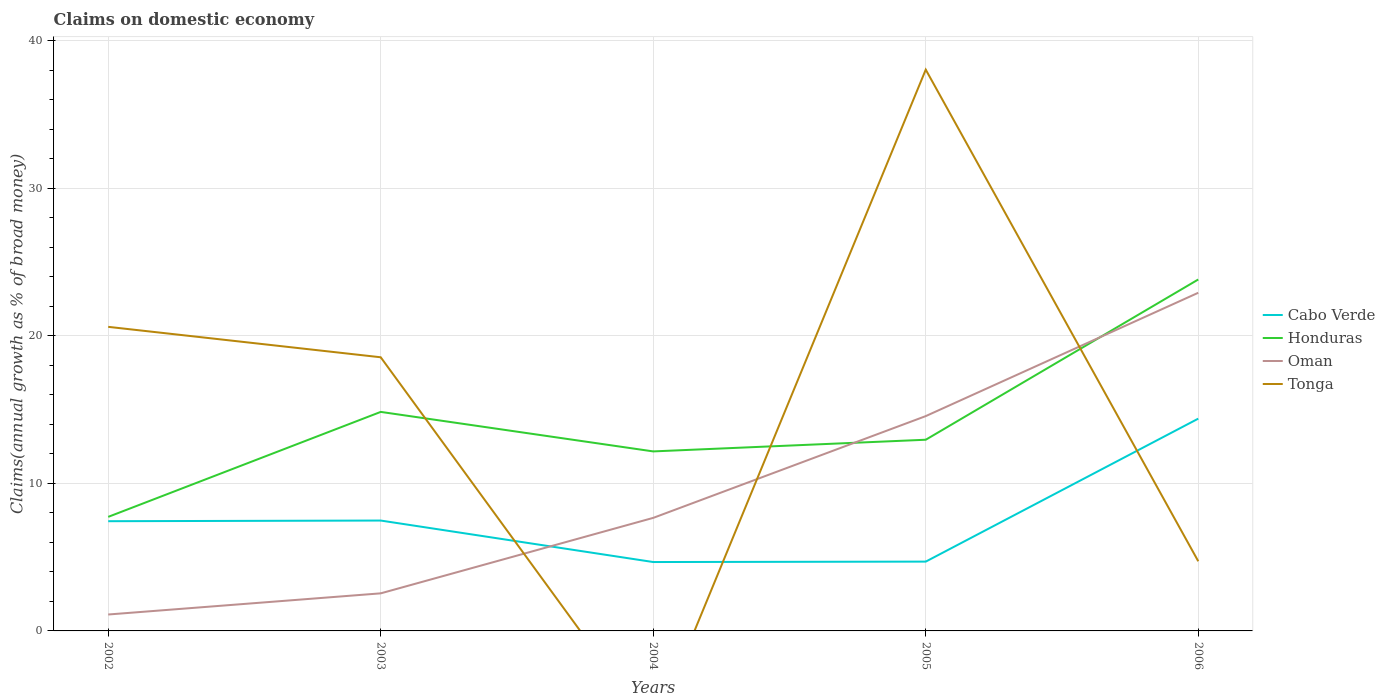How many different coloured lines are there?
Give a very brief answer. 4. Does the line corresponding to Tonga intersect with the line corresponding to Cabo Verde?
Keep it short and to the point. Yes. Is the number of lines equal to the number of legend labels?
Offer a very short reply. No. What is the total percentage of broad money claimed on domestic economy in Honduras in the graph?
Ensure brevity in your answer.  -11.65. What is the difference between the highest and the second highest percentage of broad money claimed on domestic economy in Cabo Verde?
Ensure brevity in your answer.  9.72. Is the percentage of broad money claimed on domestic economy in Cabo Verde strictly greater than the percentage of broad money claimed on domestic economy in Oman over the years?
Provide a succinct answer. No. How many lines are there?
Your answer should be very brief. 4. How many years are there in the graph?
Give a very brief answer. 5. Are the values on the major ticks of Y-axis written in scientific E-notation?
Offer a very short reply. No. Does the graph contain grids?
Ensure brevity in your answer.  Yes. Where does the legend appear in the graph?
Keep it short and to the point. Center right. How many legend labels are there?
Keep it short and to the point. 4. What is the title of the graph?
Give a very brief answer. Claims on domestic economy. What is the label or title of the X-axis?
Give a very brief answer. Years. What is the label or title of the Y-axis?
Give a very brief answer. Claims(annual growth as % of broad money). What is the Claims(annual growth as % of broad money) in Cabo Verde in 2002?
Your answer should be compact. 7.44. What is the Claims(annual growth as % of broad money) in Honduras in 2002?
Offer a very short reply. 7.73. What is the Claims(annual growth as % of broad money) in Oman in 2002?
Make the answer very short. 1.11. What is the Claims(annual growth as % of broad money) in Tonga in 2002?
Provide a succinct answer. 20.61. What is the Claims(annual growth as % of broad money) of Cabo Verde in 2003?
Your answer should be very brief. 7.48. What is the Claims(annual growth as % of broad money) of Honduras in 2003?
Provide a short and direct response. 14.84. What is the Claims(annual growth as % of broad money) in Oman in 2003?
Ensure brevity in your answer.  2.55. What is the Claims(annual growth as % of broad money) in Tonga in 2003?
Provide a succinct answer. 18.55. What is the Claims(annual growth as % of broad money) in Cabo Verde in 2004?
Give a very brief answer. 4.67. What is the Claims(annual growth as % of broad money) of Honduras in 2004?
Provide a succinct answer. 12.17. What is the Claims(annual growth as % of broad money) of Oman in 2004?
Your answer should be compact. 7.66. What is the Claims(annual growth as % of broad money) of Cabo Verde in 2005?
Your answer should be compact. 4.7. What is the Claims(annual growth as % of broad money) in Honduras in 2005?
Provide a succinct answer. 12.96. What is the Claims(annual growth as % of broad money) in Oman in 2005?
Make the answer very short. 14.56. What is the Claims(annual growth as % of broad money) in Tonga in 2005?
Your answer should be very brief. 38.04. What is the Claims(annual growth as % of broad money) of Cabo Verde in 2006?
Provide a succinct answer. 14.39. What is the Claims(annual growth as % of broad money) of Honduras in 2006?
Provide a short and direct response. 23.82. What is the Claims(annual growth as % of broad money) of Oman in 2006?
Your answer should be compact. 22.92. What is the Claims(annual growth as % of broad money) of Tonga in 2006?
Provide a succinct answer. 4.72. Across all years, what is the maximum Claims(annual growth as % of broad money) in Cabo Verde?
Provide a short and direct response. 14.39. Across all years, what is the maximum Claims(annual growth as % of broad money) in Honduras?
Your response must be concise. 23.82. Across all years, what is the maximum Claims(annual growth as % of broad money) in Oman?
Your answer should be very brief. 22.92. Across all years, what is the maximum Claims(annual growth as % of broad money) of Tonga?
Provide a short and direct response. 38.04. Across all years, what is the minimum Claims(annual growth as % of broad money) in Cabo Verde?
Make the answer very short. 4.67. Across all years, what is the minimum Claims(annual growth as % of broad money) of Honduras?
Provide a succinct answer. 7.73. Across all years, what is the minimum Claims(annual growth as % of broad money) in Oman?
Make the answer very short. 1.11. Across all years, what is the minimum Claims(annual growth as % of broad money) in Tonga?
Make the answer very short. 0. What is the total Claims(annual growth as % of broad money) in Cabo Verde in the graph?
Your answer should be compact. 38.67. What is the total Claims(annual growth as % of broad money) in Honduras in the graph?
Provide a short and direct response. 71.52. What is the total Claims(annual growth as % of broad money) of Oman in the graph?
Your answer should be very brief. 48.8. What is the total Claims(annual growth as % of broad money) of Tonga in the graph?
Offer a terse response. 81.92. What is the difference between the Claims(annual growth as % of broad money) in Cabo Verde in 2002 and that in 2003?
Offer a terse response. -0.05. What is the difference between the Claims(annual growth as % of broad money) of Honduras in 2002 and that in 2003?
Offer a very short reply. -7.11. What is the difference between the Claims(annual growth as % of broad money) of Oman in 2002 and that in 2003?
Keep it short and to the point. -1.43. What is the difference between the Claims(annual growth as % of broad money) in Tonga in 2002 and that in 2003?
Your answer should be very brief. 2.06. What is the difference between the Claims(annual growth as % of broad money) of Cabo Verde in 2002 and that in 2004?
Offer a very short reply. 2.77. What is the difference between the Claims(annual growth as % of broad money) in Honduras in 2002 and that in 2004?
Provide a succinct answer. -4.44. What is the difference between the Claims(annual growth as % of broad money) of Oman in 2002 and that in 2004?
Your response must be concise. -6.55. What is the difference between the Claims(annual growth as % of broad money) of Cabo Verde in 2002 and that in 2005?
Make the answer very short. 2.74. What is the difference between the Claims(annual growth as % of broad money) in Honduras in 2002 and that in 2005?
Make the answer very short. -5.23. What is the difference between the Claims(annual growth as % of broad money) of Oman in 2002 and that in 2005?
Offer a very short reply. -13.45. What is the difference between the Claims(annual growth as % of broad money) of Tonga in 2002 and that in 2005?
Offer a terse response. -17.43. What is the difference between the Claims(annual growth as % of broad money) of Cabo Verde in 2002 and that in 2006?
Your response must be concise. -6.95. What is the difference between the Claims(annual growth as % of broad money) in Honduras in 2002 and that in 2006?
Your response must be concise. -16.09. What is the difference between the Claims(annual growth as % of broad money) of Oman in 2002 and that in 2006?
Your response must be concise. -21.81. What is the difference between the Claims(annual growth as % of broad money) of Tonga in 2002 and that in 2006?
Your answer should be compact. 15.89. What is the difference between the Claims(annual growth as % of broad money) in Cabo Verde in 2003 and that in 2004?
Your response must be concise. 2.81. What is the difference between the Claims(annual growth as % of broad money) in Honduras in 2003 and that in 2004?
Provide a short and direct response. 2.68. What is the difference between the Claims(annual growth as % of broad money) in Oman in 2003 and that in 2004?
Ensure brevity in your answer.  -5.12. What is the difference between the Claims(annual growth as % of broad money) in Cabo Verde in 2003 and that in 2005?
Provide a succinct answer. 2.78. What is the difference between the Claims(annual growth as % of broad money) in Honduras in 2003 and that in 2005?
Your response must be concise. 1.89. What is the difference between the Claims(annual growth as % of broad money) in Oman in 2003 and that in 2005?
Your answer should be compact. -12.01. What is the difference between the Claims(annual growth as % of broad money) of Tonga in 2003 and that in 2005?
Make the answer very short. -19.5. What is the difference between the Claims(annual growth as % of broad money) of Cabo Verde in 2003 and that in 2006?
Give a very brief answer. -6.91. What is the difference between the Claims(annual growth as % of broad money) in Honduras in 2003 and that in 2006?
Offer a terse response. -8.98. What is the difference between the Claims(annual growth as % of broad money) in Oman in 2003 and that in 2006?
Provide a succinct answer. -20.37. What is the difference between the Claims(annual growth as % of broad money) of Tonga in 2003 and that in 2006?
Your answer should be compact. 13.83. What is the difference between the Claims(annual growth as % of broad money) of Cabo Verde in 2004 and that in 2005?
Your response must be concise. -0.03. What is the difference between the Claims(annual growth as % of broad money) of Honduras in 2004 and that in 2005?
Your answer should be very brief. -0.79. What is the difference between the Claims(annual growth as % of broad money) of Oman in 2004 and that in 2005?
Ensure brevity in your answer.  -6.9. What is the difference between the Claims(annual growth as % of broad money) in Cabo Verde in 2004 and that in 2006?
Provide a succinct answer. -9.72. What is the difference between the Claims(annual growth as % of broad money) of Honduras in 2004 and that in 2006?
Provide a succinct answer. -11.65. What is the difference between the Claims(annual growth as % of broad money) in Oman in 2004 and that in 2006?
Ensure brevity in your answer.  -15.26. What is the difference between the Claims(annual growth as % of broad money) in Cabo Verde in 2005 and that in 2006?
Give a very brief answer. -9.69. What is the difference between the Claims(annual growth as % of broad money) in Honduras in 2005 and that in 2006?
Offer a very short reply. -10.86. What is the difference between the Claims(annual growth as % of broad money) of Oman in 2005 and that in 2006?
Your answer should be very brief. -8.36. What is the difference between the Claims(annual growth as % of broad money) in Tonga in 2005 and that in 2006?
Your response must be concise. 33.32. What is the difference between the Claims(annual growth as % of broad money) in Cabo Verde in 2002 and the Claims(annual growth as % of broad money) in Honduras in 2003?
Your answer should be compact. -7.41. What is the difference between the Claims(annual growth as % of broad money) in Cabo Verde in 2002 and the Claims(annual growth as % of broad money) in Oman in 2003?
Your answer should be compact. 4.89. What is the difference between the Claims(annual growth as % of broad money) in Cabo Verde in 2002 and the Claims(annual growth as % of broad money) in Tonga in 2003?
Keep it short and to the point. -11.11. What is the difference between the Claims(annual growth as % of broad money) in Honduras in 2002 and the Claims(annual growth as % of broad money) in Oman in 2003?
Your answer should be compact. 5.18. What is the difference between the Claims(annual growth as % of broad money) in Honduras in 2002 and the Claims(annual growth as % of broad money) in Tonga in 2003?
Provide a succinct answer. -10.82. What is the difference between the Claims(annual growth as % of broad money) of Oman in 2002 and the Claims(annual growth as % of broad money) of Tonga in 2003?
Make the answer very short. -17.43. What is the difference between the Claims(annual growth as % of broad money) in Cabo Verde in 2002 and the Claims(annual growth as % of broad money) in Honduras in 2004?
Provide a succinct answer. -4.73. What is the difference between the Claims(annual growth as % of broad money) in Cabo Verde in 2002 and the Claims(annual growth as % of broad money) in Oman in 2004?
Keep it short and to the point. -0.23. What is the difference between the Claims(annual growth as % of broad money) of Honduras in 2002 and the Claims(annual growth as % of broad money) of Oman in 2004?
Your answer should be very brief. 0.07. What is the difference between the Claims(annual growth as % of broad money) of Cabo Verde in 2002 and the Claims(annual growth as % of broad money) of Honduras in 2005?
Provide a short and direct response. -5.52. What is the difference between the Claims(annual growth as % of broad money) of Cabo Verde in 2002 and the Claims(annual growth as % of broad money) of Oman in 2005?
Your answer should be very brief. -7.12. What is the difference between the Claims(annual growth as % of broad money) in Cabo Verde in 2002 and the Claims(annual growth as % of broad money) in Tonga in 2005?
Your answer should be very brief. -30.61. What is the difference between the Claims(annual growth as % of broad money) in Honduras in 2002 and the Claims(annual growth as % of broad money) in Oman in 2005?
Offer a very short reply. -6.83. What is the difference between the Claims(annual growth as % of broad money) in Honduras in 2002 and the Claims(annual growth as % of broad money) in Tonga in 2005?
Ensure brevity in your answer.  -30.31. What is the difference between the Claims(annual growth as % of broad money) in Oman in 2002 and the Claims(annual growth as % of broad money) in Tonga in 2005?
Keep it short and to the point. -36.93. What is the difference between the Claims(annual growth as % of broad money) in Cabo Verde in 2002 and the Claims(annual growth as % of broad money) in Honduras in 2006?
Give a very brief answer. -16.38. What is the difference between the Claims(annual growth as % of broad money) of Cabo Verde in 2002 and the Claims(annual growth as % of broad money) of Oman in 2006?
Provide a short and direct response. -15.48. What is the difference between the Claims(annual growth as % of broad money) in Cabo Verde in 2002 and the Claims(annual growth as % of broad money) in Tonga in 2006?
Offer a terse response. 2.71. What is the difference between the Claims(annual growth as % of broad money) in Honduras in 2002 and the Claims(annual growth as % of broad money) in Oman in 2006?
Your answer should be compact. -15.19. What is the difference between the Claims(annual growth as % of broad money) of Honduras in 2002 and the Claims(annual growth as % of broad money) of Tonga in 2006?
Provide a succinct answer. 3.01. What is the difference between the Claims(annual growth as % of broad money) in Oman in 2002 and the Claims(annual growth as % of broad money) in Tonga in 2006?
Provide a short and direct response. -3.61. What is the difference between the Claims(annual growth as % of broad money) of Cabo Verde in 2003 and the Claims(annual growth as % of broad money) of Honduras in 2004?
Provide a succinct answer. -4.69. What is the difference between the Claims(annual growth as % of broad money) in Cabo Verde in 2003 and the Claims(annual growth as % of broad money) in Oman in 2004?
Provide a short and direct response. -0.18. What is the difference between the Claims(annual growth as % of broad money) of Honduras in 2003 and the Claims(annual growth as % of broad money) of Oman in 2004?
Provide a succinct answer. 7.18. What is the difference between the Claims(annual growth as % of broad money) in Cabo Verde in 2003 and the Claims(annual growth as % of broad money) in Honduras in 2005?
Provide a succinct answer. -5.48. What is the difference between the Claims(annual growth as % of broad money) of Cabo Verde in 2003 and the Claims(annual growth as % of broad money) of Oman in 2005?
Ensure brevity in your answer.  -7.08. What is the difference between the Claims(annual growth as % of broad money) of Cabo Verde in 2003 and the Claims(annual growth as % of broad money) of Tonga in 2005?
Provide a short and direct response. -30.56. What is the difference between the Claims(annual growth as % of broad money) of Honduras in 2003 and the Claims(annual growth as % of broad money) of Oman in 2005?
Provide a short and direct response. 0.28. What is the difference between the Claims(annual growth as % of broad money) of Honduras in 2003 and the Claims(annual growth as % of broad money) of Tonga in 2005?
Offer a terse response. -23.2. What is the difference between the Claims(annual growth as % of broad money) in Oman in 2003 and the Claims(annual growth as % of broad money) in Tonga in 2005?
Give a very brief answer. -35.5. What is the difference between the Claims(annual growth as % of broad money) in Cabo Verde in 2003 and the Claims(annual growth as % of broad money) in Honduras in 2006?
Your response must be concise. -16.34. What is the difference between the Claims(annual growth as % of broad money) in Cabo Verde in 2003 and the Claims(annual growth as % of broad money) in Oman in 2006?
Provide a short and direct response. -15.44. What is the difference between the Claims(annual growth as % of broad money) of Cabo Verde in 2003 and the Claims(annual growth as % of broad money) of Tonga in 2006?
Offer a terse response. 2.76. What is the difference between the Claims(annual growth as % of broad money) of Honduras in 2003 and the Claims(annual growth as % of broad money) of Oman in 2006?
Ensure brevity in your answer.  -8.07. What is the difference between the Claims(annual growth as % of broad money) of Honduras in 2003 and the Claims(annual growth as % of broad money) of Tonga in 2006?
Give a very brief answer. 10.12. What is the difference between the Claims(annual growth as % of broad money) in Oman in 2003 and the Claims(annual growth as % of broad money) in Tonga in 2006?
Provide a succinct answer. -2.17. What is the difference between the Claims(annual growth as % of broad money) in Cabo Verde in 2004 and the Claims(annual growth as % of broad money) in Honduras in 2005?
Your response must be concise. -8.29. What is the difference between the Claims(annual growth as % of broad money) in Cabo Verde in 2004 and the Claims(annual growth as % of broad money) in Oman in 2005?
Offer a very short reply. -9.89. What is the difference between the Claims(annual growth as % of broad money) of Cabo Verde in 2004 and the Claims(annual growth as % of broad money) of Tonga in 2005?
Give a very brief answer. -33.37. What is the difference between the Claims(annual growth as % of broad money) in Honduras in 2004 and the Claims(annual growth as % of broad money) in Oman in 2005?
Your answer should be compact. -2.39. What is the difference between the Claims(annual growth as % of broad money) in Honduras in 2004 and the Claims(annual growth as % of broad money) in Tonga in 2005?
Your response must be concise. -25.88. What is the difference between the Claims(annual growth as % of broad money) of Oman in 2004 and the Claims(annual growth as % of broad money) of Tonga in 2005?
Ensure brevity in your answer.  -30.38. What is the difference between the Claims(annual growth as % of broad money) of Cabo Verde in 2004 and the Claims(annual growth as % of broad money) of Honduras in 2006?
Your answer should be very brief. -19.15. What is the difference between the Claims(annual growth as % of broad money) of Cabo Verde in 2004 and the Claims(annual growth as % of broad money) of Oman in 2006?
Provide a short and direct response. -18.25. What is the difference between the Claims(annual growth as % of broad money) of Cabo Verde in 2004 and the Claims(annual growth as % of broad money) of Tonga in 2006?
Your answer should be compact. -0.05. What is the difference between the Claims(annual growth as % of broad money) in Honduras in 2004 and the Claims(annual growth as % of broad money) in Oman in 2006?
Offer a very short reply. -10.75. What is the difference between the Claims(annual growth as % of broad money) in Honduras in 2004 and the Claims(annual growth as % of broad money) in Tonga in 2006?
Offer a very short reply. 7.45. What is the difference between the Claims(annual growth as % of broad money) in Oman in 2004 and the Claims(annual growth as % of broad money) in Tonga in 2006?
Your answer should be compact. 2.94. What is the difference between the Claims(annual growth as % of broad money) in Cabo Verde in 2005 and the Claims(annual growth as % of broad money) in Honduras in 2006?
Offer a very short reply. -19.12. What is the difference between the Claims(annual growth as % of broad money) in Cabo Verde in 2005 and the Claims(annual growth as % of broad money) in Oman in 2006?
Keep it short and to the point. -18.22. What is the difference between the Claims(annual growth as % of broad money) in Cabo Verde in 2005 and the Claims(annual growth as % of broad money) in Tonga in 2006?
Give a very brief answer. -0.02. What is the difference between the Claims(annual growth as % of broad money) of Honduras in 2005 and the Claims(annual growth as % of broad money) of Oman in 2006?
Keep it short and to the point. -9.96. What is the difference between the Claims(annual growth as % of broad money) of Honduras in 2005 and the Claims(annual growth as % of broad money) of Tonga in 2006?
Offer a terse response. 8.24. What is the difference between the Claims(annual growth as % of broad money) of Oman in 2005 and the Claims(annual growth as % of broad money) of Tonga in 2006?
Provide a short and direct response. 9.84. What is the average Claims(annual growth as % of broad money) of Cabo Verde per year?
Ensure brevity in your answer.  7.73. What is the average Claims(annual growth as % of broad money) of Honduras per year?
Your response must be concise. 14.3. What is the average Claims(annual growth as % of broad money) of Oman per year?
Offer a very short reply. 9.76. What is the average Claims(annual growth as % of broad money) of Tonga per year?
Offer a terse response. 16.38. In the year 2002, what is the difference between the Claims(annual growth as % of broad money) of Cabo Verde and Claims(annual growth as % of broad money) of Honduras?
Keep it short and to the point. -0.29. In the year 2002, what is the difference between the Claims(annual growth as % of broad money) in Cabo Verde and Claims(annual growth as % of broad money) in Oman?
Provide a succinct answer. 6.32. In the year 2002, what is the difference between the Claims(annual growth as % of broad money) of Cabo Verde and Claims(annual growth as % of broad money) of Tonga?
Offer a terse response. -13.17. In the year 2002, what is the difference between the Claims(annual growth as % of broad money) of Honduras and Claims(annual growth as % of broad money) of Oman?
Offer a terse response. 6.62. In the year 2002, what is the difference between the Claims(annual growth as % of broad money) of Honduras and Claims(annual growth as % of broad money) of Tonga?
Provide a short and direct response. -12.88. In the year 2002, what is the difference between the Claims(annual growth as % of broad money) in Oman and Claims(annual growth as % of broad money) in Tonga?
Offer a terse response. -19.5. In the year 2003, what is the difference between the Claims(annual growth as % of broad money) of Cabo Verde and Claims(annual growth as % of broad money) of Honduras?
Provide a short and direct response. -7.36. In the year 2003, what is the difference between the Claims(annual growth as % of broad money) in Cabo Verde and Claims(annual growth as % of broad money) in Oman?
Give a very brief answer. 4.93. In the year 2003, what is the difference between the Claims(annual growth as % of broad money) in Cabo Verde and Claims(annual growth as % of broad money) in Tonga?
Your answer should be very brief. -11.07. In the year 2003, what is the difference between the Claims(annual growth as % of broad money) of Honduras and Claims(annual growth as % of broad money) of Oman?
Make the answer very short. 12.3. In the year 2003, what is the difference between the Claims(annual growth as % of broad money) in Honduras and Claims(annual growth as % of broad money) in Tonga?
Ensure brevity in your answer.  -3.7. In the year 2003, what is the difference between the Claims(annual growth as % of broad money) in Oman and Claims(annual growth as % of broad money) in Tonga?
Your answer should be very brief. -16. In the year 2004, what is the difference between the Claims(annual growth as % of broad money) of Cabo Verde and Claims(annual growth as % of broad money) of Honduras?
Keep it short and to the point. -7.5. In the year 2004, what is the difference between the Claims(annual growth as % of broad money) of Cabo Verde and Claims(annual growth as % of broad money) of Oman?
Ensure brevity in your answer.  -2.99. In the year 2004, what is the difference between the Claims(annual growth as % of broad money) of Honduras and Claims(annual growth as % of broad money) of Oman?
Provide a short and direct response. 4.5. In the year 2005, what is the difference between the Claims(annual growth as % of broad money) of Cabo Verde and Claims(annual growth as % of broad money) of Honduras?
Your answer should be compact. -8.26. In the year 2005, what is the difference between the Claims(annual growth as % of broad money) in Cabo Verde and Claims(annual growth as % of broad money) in Oman?
Keep it short and to the point. -9.86. In the year 2005, what is the difference between the Claims(annual growth as % of broad money) in Cabo Verde and Claims(annual growth as % of broad money) in Tonga?
Offer a terse response. -33.35. In the year 2005, what is the difference between the Claims(annual growth as % of broad money) in Honduras and Claims(annual growth as % of broad money) in Oman?
Your answer should be very brief. -1.6. In the year 2005, what is the difference between the Claims(annual growth as % of broad money) of Honduras and Claims(annual growth as % of broad money) of Tonga?
Keep it short and to the point. -25.08. In the year 2005, what is the difference between the Claims(annual growth as % of broad money) in Oman and Claims(annual growth as % of broad money) in Tonga?
Provide a succinct answer. -23.48. In the year 2006, what is the difference between the Claims(annual growth as % of broad money) of Cabo Verde and Claims(annual growth as % of broad money) of Honduras?
Offer a very short reply. -9.43. In the year 2006, what is the difference between the Claims(annual growth as % of broad money) of Cabo Verde and Claims(annual growth as % of broad money) of Oman?
Offer a very short reply. -8.53. In the year 2006, what is the difference between the Claims(annual growth as % of broad money) in Cabo Verde and Claims(annual growth as % of broad money) in Tonga?
Give a very brief answer. 9.67. In the year 2006, what is the difference between the Claims(annual growth as % of broad money) in Honduras and Claims(annual growth as % of broad money) in Oman?
Your response must be concise. 0.9. In the year 2006, what is the difference between the Claims(annual growth as % of broad money) in Honduras and Claims(annual growth as % of broad money) in Tonga?
Ensure brevity in your answer.  19.1. In the year 2006, what is the difference between the Claims(annual growth as % of broad money) in Oman and Claims(annual growth as % of broad money) in Tonga?
Your answer should be very brief. 18.2. What is the ratio of the Claims(annual growth as % of broad money) of Cabo Verde in 2002 to that in 2003?
Your response must be concise. 0.99. What is the ratio of the Claims(annual growth as % of broad money) in Honduras in 2002 to that in 2003?
Provide a short and direct response. 0.52. What is the ratio of the Claims(annual growth as % of broad money) of Oman in 2002 to that in 2003?
Your response must be concise. 0.44. What is the ratio of the Claims(annual growth as % of broad money) in Tonga in 2002 to that in 2003?
Your response must be concise. 1.11. What is the ratio of the Claims(annual growth as % of broad money) of Cabo Verde in 2002 to that in 2004?
Offer a terse response. 1.59. What is the ratio of the Claims(annual growth as % of broad money) in Honduras in 2002 to that in 2004?
Ensure brevity in your answer.  0.64. What is the ratio of the Claims(annual growth as % of broad money) in Oman in 2002 to that in 2004?
Provide a succinct answer. 0.15. What is the ratio of the Claims(annual growth as % of broad money) of Cabo Verde in 2002 to that in 2005?
Offer a terse response. 1.58. What is the ratio of the Claims(annual growth as % of broad money) in Honduras in 2002 to that in 2005?
Keep it short and to the point. 0.6. What is the ratio of the Claims(annual growth as % of broad money) in Oman in 2002 to that in 2005?
Ensure brevity in your answer.  0.08. What is the ratio of the Claims(annual growth as % of broad money) of Tonga in 2002 to that in 2005?
Your answer should be compact. 0.54. What is the ratio of the Claims(annual growth as % of broad money) of Cabo Verde in 2002 to that in 2006?
Offer a very short reply. 0.52. What is the ratio of the Claims(annual growth as % of broad money) in Honduras in 2002 to that in 2006?
Your answer should be very brief. 0.32. What is the ratio of the Claims(annual growth as % of broad money) of Oman in 2002 to that in 2006?
Give a very brief answer. 0.05. What is the ratio of the Claims(annual growth as % of broad money) of Tonga in 2002 to that in 2006?
Give a very brief answer. 4.37. What is the ratio of the Claims(annual growth as % of broad money) of Cabo Verde in 2003 to that in 2004?
Keep it short and to the point. 1.6. What is the ratio of the Claims(annual growth as % of broad money) of Honduras in 2003 to that in 2004?
Your answer should be very brief. 1.22. What is the ratio of the Claims(annual growth as % of broad money) of Oman in 2003 to that in 2004?
Keep it short and to the point. 0.33. What is the ratio of the Claims(annual growth as % of broad money) in Cabo Verde in 2003 to that in 2005?
Your answer should be compact. 1.59. What is the ratio of the Claims(annual growth as % of broad money) of Honduras in 2003 to that in 2005?
Your answer should be compact. 1.15. What is the ratio of the Claims(annual growth as % of broad money) of Oman in 2003 to that in 2005?
Your answer should be compact. 0.17. What is the ratio of the Claims(annual growth as % of broad money) of Tonga in 2003 to that in 2005?
Your response must be concise. 0.49. What is the ratio of the Claims(annual growth as % of broad money) in Cabo Verde in 2003 to that in 2006?
Make the answer very short. 0.52. What is the ratio of the Claims(annual growth as % of broad money) of Honduras in 2003 to that in 2006?
Your response must be concise. 0.62. What is the ratio of the Claims(annual growth as % of broad money) in Oman in 2003 to that in 2006?
Give a very brief answer. 0.11. What is the ratio of the Claims(annual growth as % of broad money) of Tonga in 2003 to that in 2006?
Ensure brevity in your answer.  3.93. What is the ratio of the Claims(annual growth as % of broad money) in Cabo Verde in 2004 to that in 2005?
Offer a terse response. 0.99. What is the ratio of the Claims(annual growth as % of broad money) of Honduras in 2004 to that in 2005?
Your answer should be compact. 0.94. What is the ratio of the Claims(annual growth as % of broad money) of Oman in 2004 to that in 2005?
Your answer should be compact. 0.53. What is the ratio of the Claims(annual growth as % of broad money) of Cabo Verde in 2004 to that in 2006?
Your answer should be very brief. 0.32. What is the ratio of the Claims(annual growth as % of broad money) in Honduras in 2004 to that in 2006?
Give a very brief answer. 0.51. What is the ratio of the Claims(annual growth as % of broad money) in Oman in 2004 to that in 2006?
Provide a succinct answer. 0.33. What is the ratio of the Claims(annual growth as % of broad money) of Cabo Verde in 2005 to that in 2006?
Offer a terse response. 0.33. What is the ratio of the Claims(annual growth as % of broad money) of Honduras in 2005 to that in 2006?
Provide a short and direct response. 0.54. What is the ratio of the Claims(annual growth as % of broad money) in Oman in 2005 to that in 2006?
Your answer should be compact. 0.64. What is the ratio of the Claims(annual growth as % of broad money) in Tonga in 2005 to that in 2006?
Make the answer very short. 8.06. What is the difference between the highest and the second highest Claims(annual growth as % of broad money) of Cabo Verde?
Provide a succinct answer. 6.91. What is the difference between the highest and the second highest Claims(annual growth as % of broad money) in Honduras?
Ensure brevity in your answer.  8.98. What is the difference between the highest and the second highest Claims(annual growth as % of broad money) of Oman?
Provide a short and direct response. 8.36. What is the difference between the highest and the second highest Claims(annual growth as % of broad money) in Tonga?
Your answer should be very brief. 17.43. What is the difference between the highest and the lowest Claims(annual growth as % of broad money) in Cabo Verde?
Offer a very short reply. 9.72. What is the difference between the highest and the lowest Claims(annual growth as % of broad money) of Honduras?
Make the answer very short. 16.09. What is the difference between the highest and the lowest Claims(annual growth as % of broad money) in Oman?
Provide a short and direct response. 21.81. What is the difference between the highest and the lowest Claims(annual growth as % of broad money) in Tonga?
Offer a terse response. 38.04. 